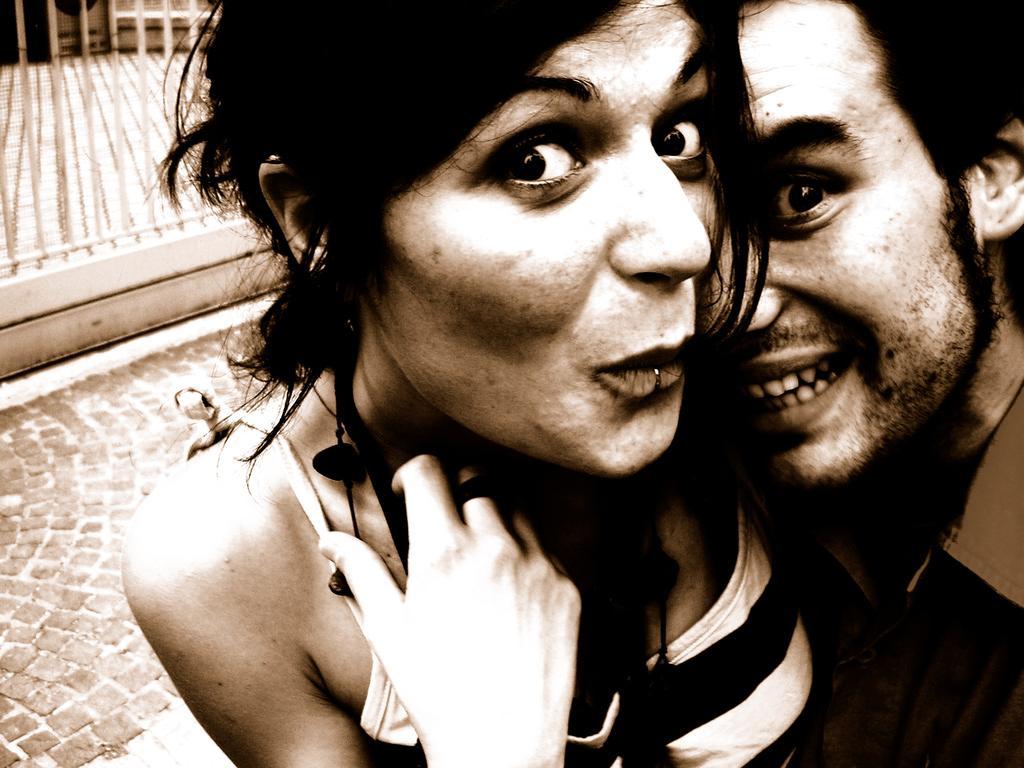Can you describe this image briefly? In this image we can see a man and woman hugging each other posing for a photograph and in the background of the image there is footpath and fencing. 